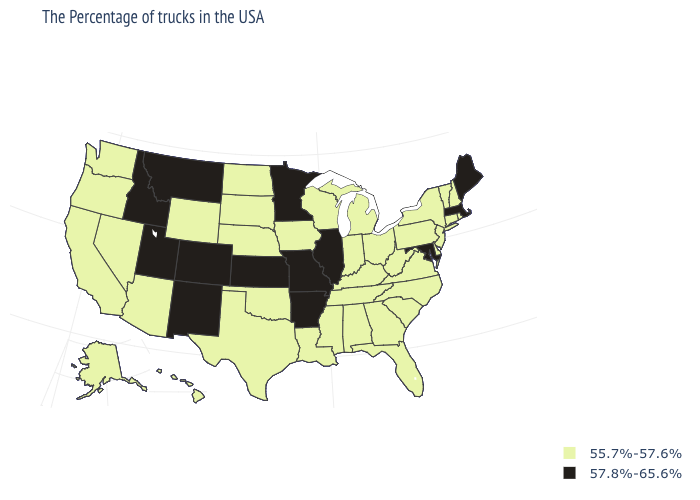Does South Carolina have a lower value than Virginia?
Be succinct. No. What is the value of Louisiana?
Concise answer only. 55.7%-57.6%. Name the states that have a value in the range 57.8%-65.6%?
Short answer required. Maine, Massachusetts, Maryland, Illinois, Missouri, Arkansas, Minnesota, Kansas, Colorado, New Mexico, Utah, Montana, Idaho. What is the value of New Jersey?
Short answer required. 55.7%-57.6%. Does Maine have the lowest value in the Northeast?
Answer briefly. No. Does the map have missing data?
Keep it brief. No. Which states have the highest value in the USA?
Write a very short answer. Maine, Massachusetts, Maryland, Illinois, Missouri, Arkansas, Minnesota, Kansas, Colorado, New Mexico, Utah, Montana, Idaho. Is the legend a continuous bar?
Short answer required. No. Name the states that have a value in the range 57.8%-65.6%?
Be succinct. Maine, Massachusetts, Maryland, Illinois, Missouri, Arkansas, Minnesota, Kansas, Colorado, New Mexico, Utah, Montana, Idaho. Does Colorado have the highest value in the USA?
Quick response, please. Yes. Among the states that border Oklahoma , which have the lowest value?
Keep it brief. Texas. Which states hav the highest value in the Northeast?
Keep it brief. Maine, Massachusetts. Among the states that border Georgia , which have the highest value?
Quick response, please. North Carolina, South Carolina, Florida, Alabama, Tennessee. What is the lowest value in the USA?
Short answer required. 55.7%-57.6%. Does Wyoming have the highest value in the West?
Write a very short answer. No. 